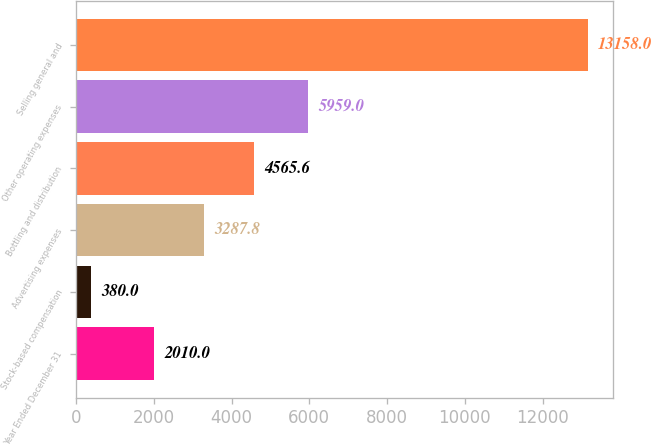Convert chart. <chart><loc_0><loc_0><loc_500><loc_500><bar_chart><fcel>Year Ended December 31<fcel>Stock-based compensation<fcel>Advertising expenses<fcel>Bottling and distribution<fcel>Other operating expenses<fcel>Selling general and<nl><fcel>2010<fcel>380<fcel>3287.8<fcel>4565.6<fcel>5959<fcel>13158<nl></chart> 